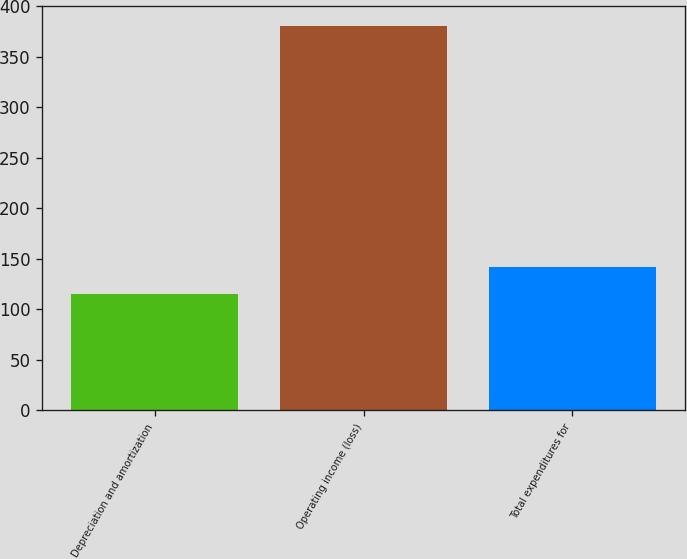<chart> <loc_0><loc_0><loc_500><loc_500><bar_chart><fcel>Depreciation and amortization<fcel>Operating income (loss)<fcel>Total expenditures for<nl><fcel>115<fcel>381<fcel>141.6<nl></chart> 